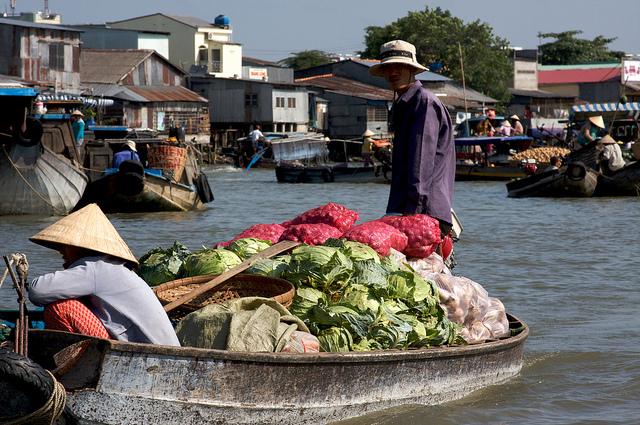Where is the boat?
Be succinct. Water. Is the boat adrift?
Short answer required. Yes. How many red bags are there?
Give a very brief answer. 5. In what part of the world is this photo taken?
Answer briefly. Asia. 